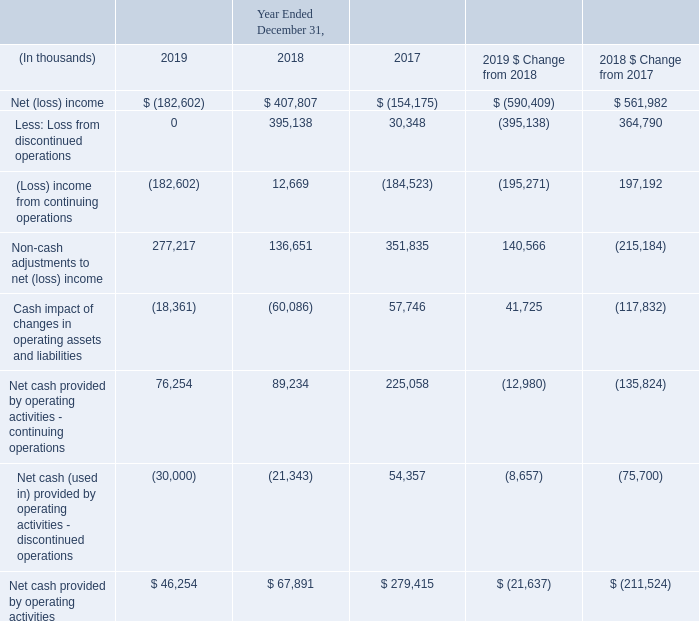Operating Cash Flow Activities
Year Ended December 31, 2019 Compared with the Year Ended December 31, 2018
Net cash provided by operating activities – continuing operations decreased during the year ended December 31, 2019 compared with prior year. The decrease in income from operations and the increase in non-cash adjustments to net income in 2019 partially related to the absence in the gains on sale of divestitures, such as OneContent in 2018.
The increase in non-cash adjustments to net loss in 2019 also related to higher depreciation and the amortization of right-to-use assets. The net loss and the cash impact of changes in operating assets and liabilities during 2019 reflects the $145 million settlement with the DOJ in connection with the Practice Fusion investigations.
Net cash used in operating activities – discontinued operations during the year ended December 31, 2019 reflects an advance income tax payment related to the gain realized on the sale of our investment in Netsmart on December 31, 2018.
Year Ended December 31, 2018 Compared with the Year Ended December 31, 2017
Net cash provided by operating activities – continuing operations decreased during the year ended December 31, 2018 compared with the prior year primarily due to working capital changes and higher costs during the year ended December 31, 2018 compared with the prior year, which primarily included higher interest expense, transaction-related and legal expenses, and incentive-based compensation payments.
The decrease in non-cash adjustments to net loss was primarily driven by lower non-cash impairment charges associated with long-term investments, intangibles and goodwill during the year ended December 31, 2018 compared with the prior year.
Net cash provided by operating activities – discontinued operations decreased during the year ended December 31, 2018 compared with the prior year primarily driven by the additional tax provision relating to the gain from the sale of our investment in Netsmart on December 31, 2018. Netsmart generated cash from operations during both 2018 and 2017. During 2018, Netsmart’s cash provided by operations decreased by approximately $16 million primarily driven by higher interest expenses paid attributable to Netsmart’s credit facilities.
What led to decrease in income from operations and the increase in non-cash adjustments to net income in 2019? Partially related to the absence in the gains on sale of divestitures, such as onecontent in 2018. What was the Net cash provided by operating activities in 2019?
Answer scale should be: thousand. $ 46,254. What led to decreased Net cash provided by operating activities – continuing operations during the year ended December 31, 2018 compared to the prior year? Due to working capital changes and higher costs during the year ended december 31, 2018 compared with the prior year, which primarily included higher interest expense, transaction-related and legal expenses, and incentive-based compensation payments. What is the change in Net (loss) income between 2019 and 2017?
Answer scale should be: thousand. -182,602-(-154,175)
Answer: -28427. What is the change in (Loss) income from continuing operations between 2019 and 2017?
Answer scale should be: thousand. -182,602-(-184,523)
Answer: 1921. What is the change in Non-cash adjustments to net (loss) income between 2019 and 2017?
Answer scale should be: thousand. 277,217-351,835
Answer: -74618. 